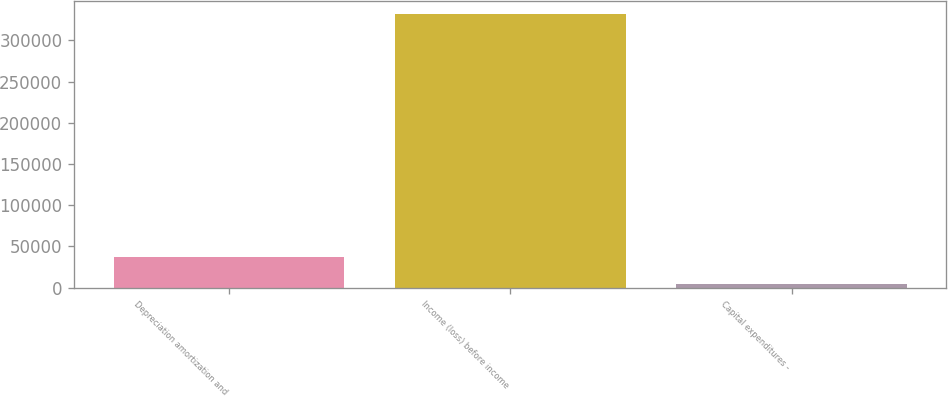<chart> <loc_0><loc_0><loc_500><loc_500><bar_chart><fcel>Depreciation amortization and<fcel>Income (loss) before income<fcel>Capital expenditures -<nl><fcel>37671<fcel>331710<fcel>5000<nl></chart> 